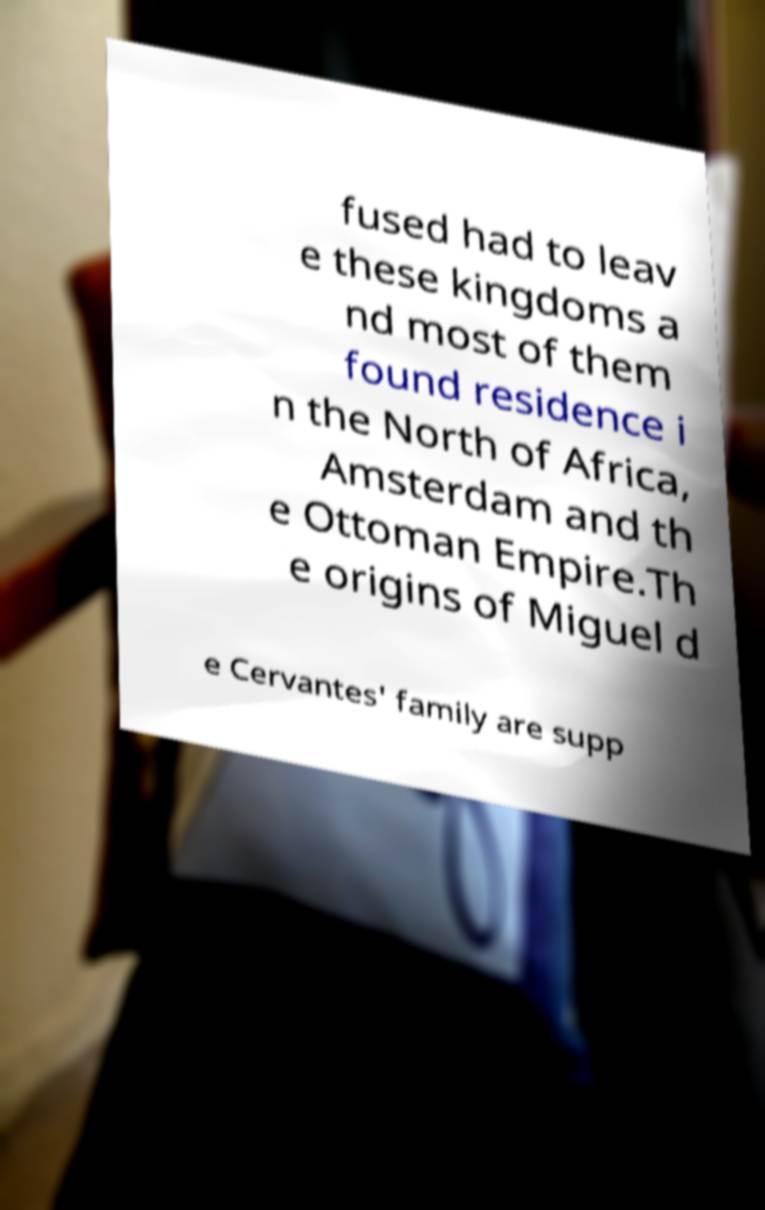Can you accurately transcribe the text from the provided image for me? fused had to leav e these kingdoms a nd most of them found residence i n the North of Africa, Amsterdam and th e Ottoman Empire.Th e origins of Miguel d e Cervantes' family are supp 